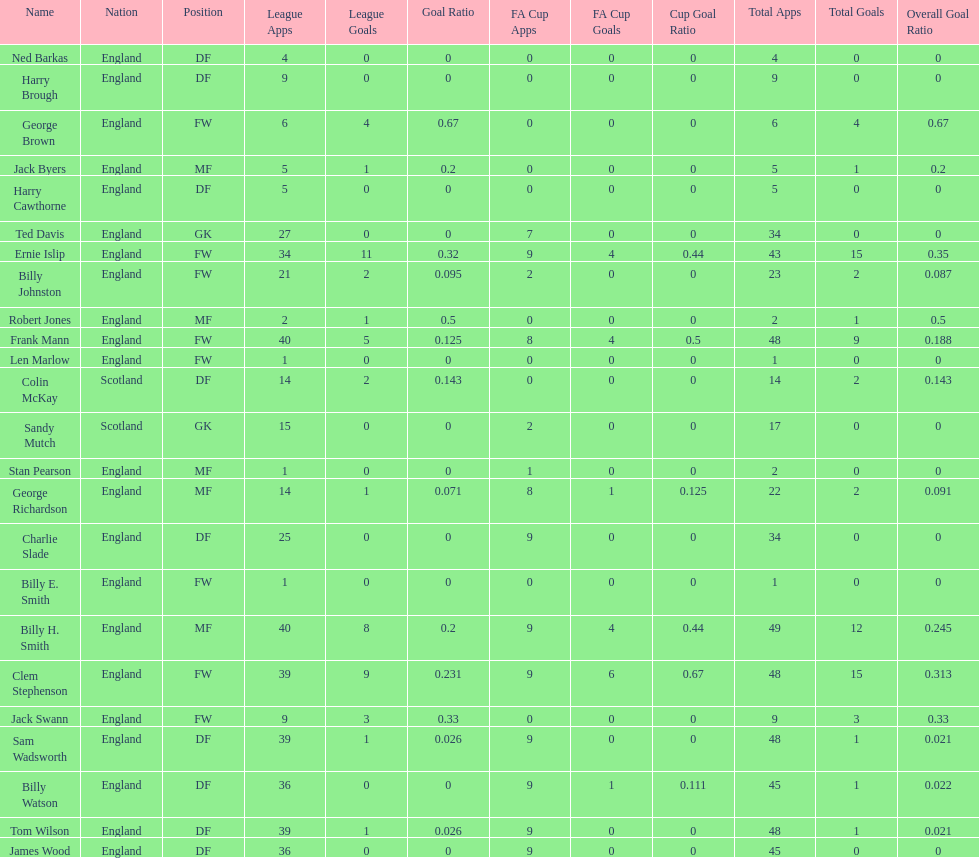Average number of goals scored by players from scotland 1. 